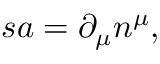Convert formula to latex. <formula><loc_0><loc_0><loc_500><loc_500>s a = \partial _ { \mu } n ^ { \mu } ,</formula> 